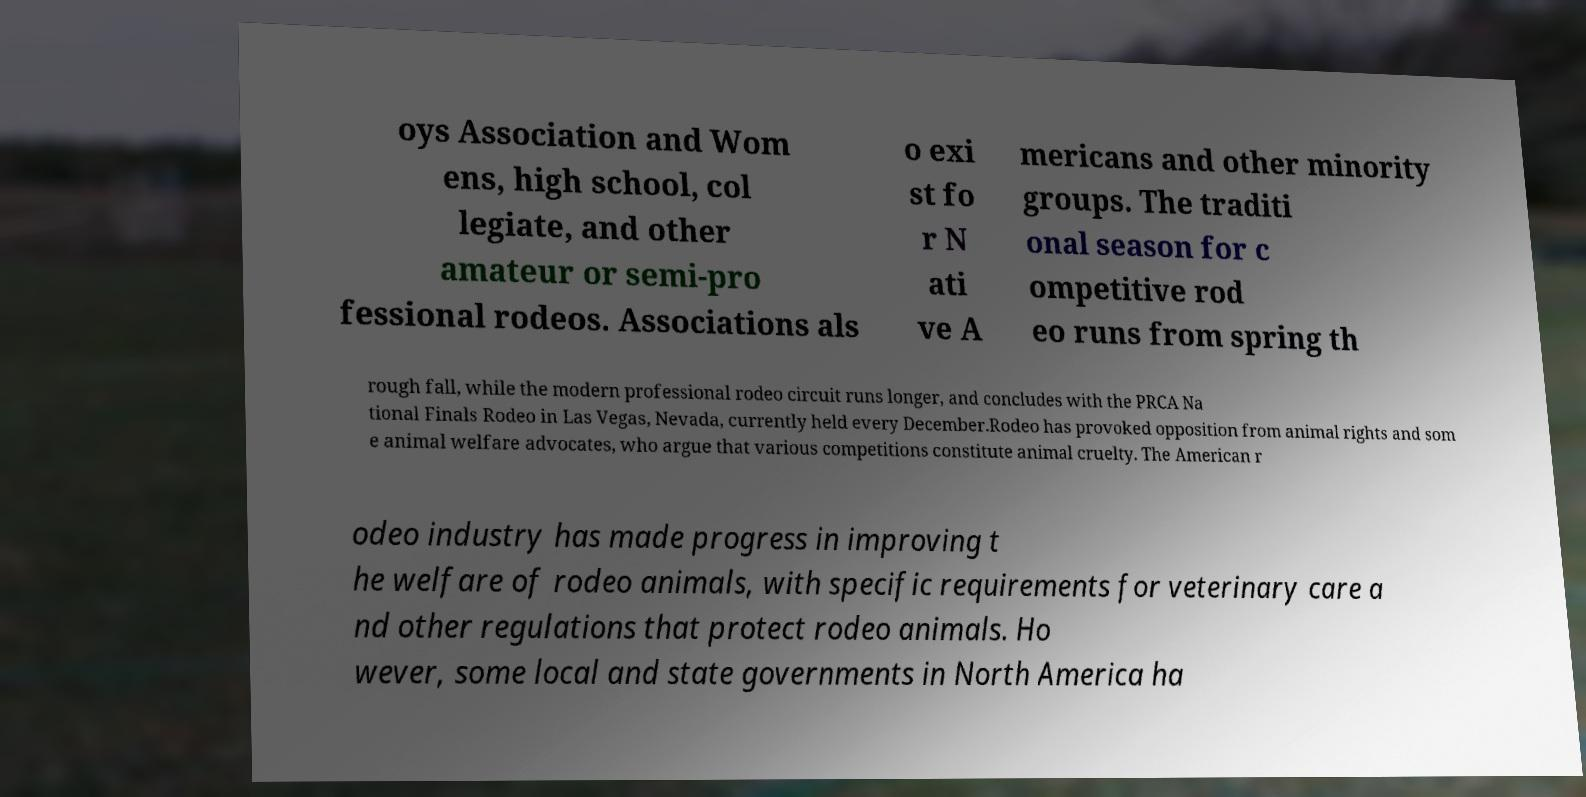Could you assist in decoding the text presented in this image and type it out clearly? oys Association and Wom ens, high school, col legiate, and other amateur or semi-pro fessional rodeos. Associations als o exi st fo r N ati ve A mericans and other minority groups. The traditi onal season for c ompetitive rod eo runs from spring th rough fall, while the modern professional rodeo circuit runs longer, and concludes with the PRCA Na tional Finals Rodeo in Las Vegas, Nevada, currently held every December.Rodeo has provoked opposition from animal rights and som e animal welfare advocates, who argue that various competitions constitute animal cruelty. The American r odeo industry has made progress in improving t he welfare of rodeo animals, with specific requirements for veterinary care a nd other regulations that protect rodeo animals. Ho wever, some local and state governments in North America ha 